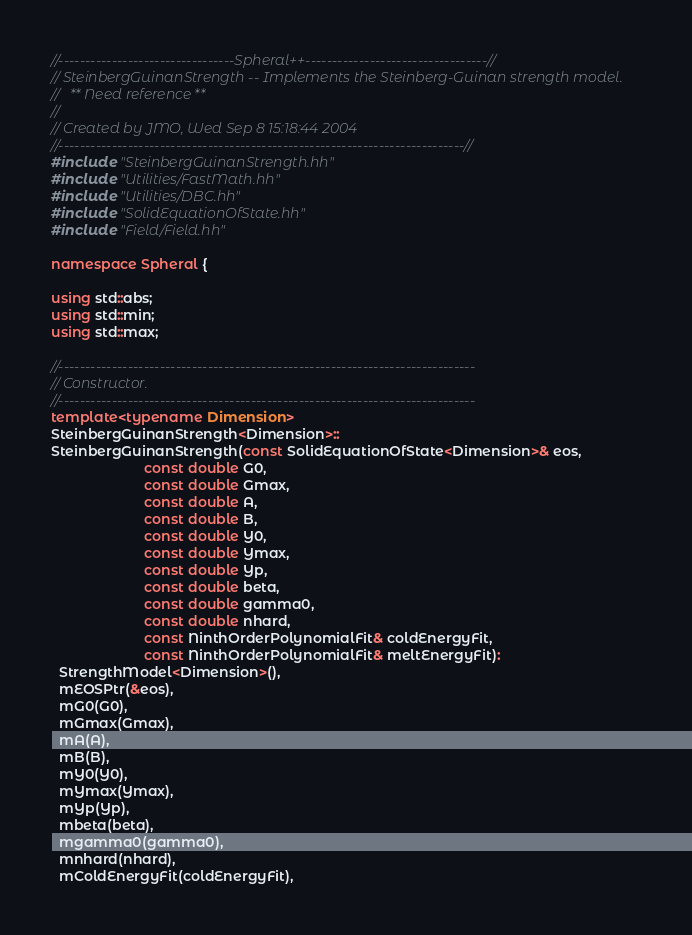Convert code to text. <code><loc_0><loc_0><loc_500><loc_500><_C++_>//---------------------------------Spheral++----------------------------------//
// SteinbergGuinanStrength -- Implements the Steinberg-Guinan strength model.
//   ** Need reference **
//
// Created by JMO, Wed Sep 8 15:18:44 2004
//----------------------------------------------------------------------------//
#include "SteinbergGuinanStrength.hh"
#include "Utilities/FastMath.hh"
#include "Utilities/DBC.hh"
#include "SolidEquationOfState.hh"
#include "Field/Field.hh"

namespace Spheral {

using std::abs;
using std::min;
using std::max;

//------------------------------------------------------------------------------
// Constructor.
//------------------------------------------------------------------------------
template<typename Dimension>
SteinbergGuinanStrength<Dimension>::
SteinbergGuinanStrength(const SolidEquationOfState<Dimension>& eos,
                        const double G0,     
                        const double Gmax,     
                        const double A,      
                        const double B,      
                        const double Y0,     
                        const double Ymax,
                        const double Yp,
                        const double beta,
                        const double gamma0, 
                        const double nhard,
                        const NinthOrderPolynomialFit& coldEnergyFit,
                        const NinthOrderPolynomialFit& meltEnergyFit):
  StrengthModel<Dimension>(),
  mEOSPtr(&eos),
  mG0(G0),
  mGmax(Gmax),
  mA(A),
  mB(B),
  mY0(Y0),
  mYmax(Ymax),
  mYp(Yp),
  mbeta(beta),
  mgamma0(gamma0),
  mnhard(nhard),
  mColdEnergyFit(coldEnergyFit),</code> 